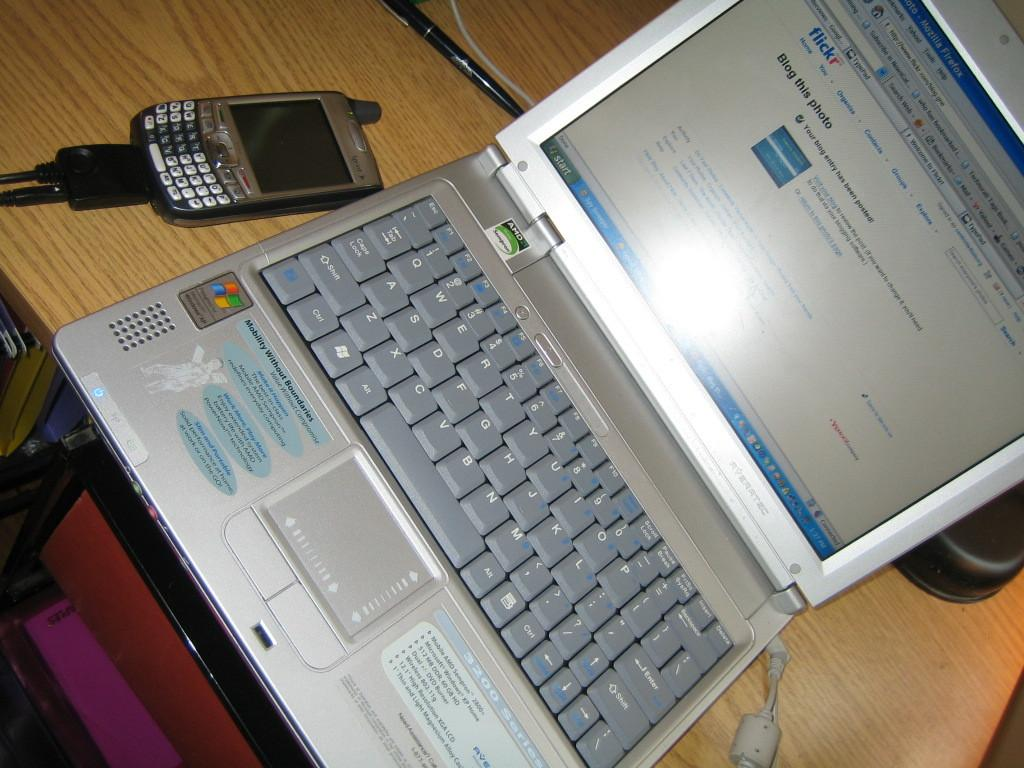<image>
Provide a brief description of the given image. A silver Windows laptop with the words Mobility Without Boundaries written on it. 